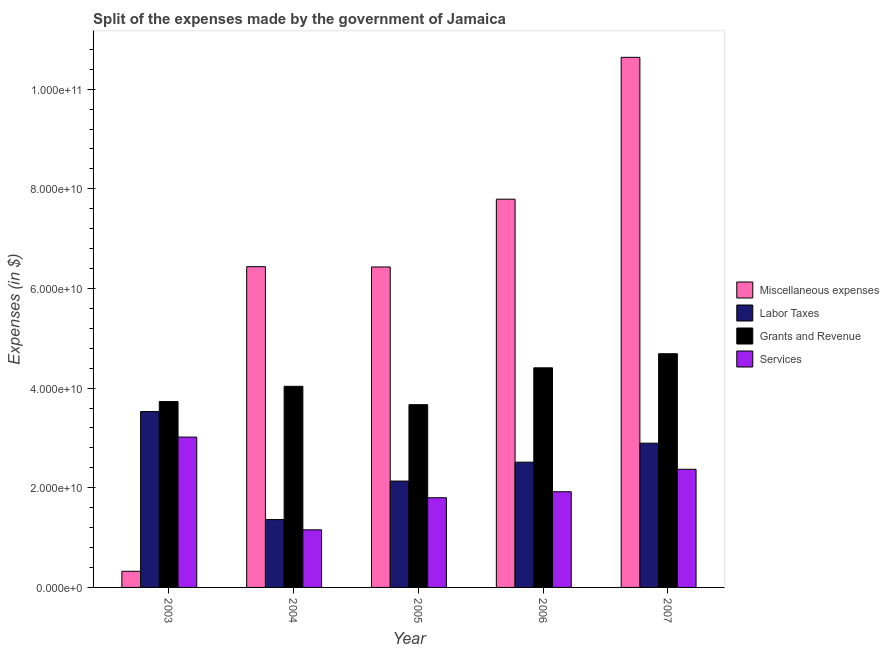How many different coloured bars are there?
Ensure brevity in your answer.  4. Are the number of bars per tick equal to the number of legend labels?
Provide a succinct answer. Yes. Are the number of bars on each tick of the X-axis equal?
Offer a very short reply. Yes. How many bars are there on the 4th tick from the right?
Make the answer very short. 4. In how many cases, is the number of bars for a given year not equal to the number of legend labels?
Give a very brief answer. 0. What is the amount spent on services in 2004?
Keep it short and to the point. 1.16e+1. Across all years, what is the maximum amount spent on services?
Your response must be concise. 3.02e+1. Across all years, what is the minimum amount spent on labor taxes?
Keep it short and to the point. 1.36e+1. In which year was the amount spent on services maximum?
Keep it short and to the point. 2003. In which year was the amount spent on labor taxes minimum?
Provide a succinct answer. 2004. What is the total amount spent on services in the graph?
Your answer should be very brief. 1.03e+11. What is the difference between the amount spent on services in 2003 and that in 2005?
Your answer should be compact. 1.22e+1. What is the difference between the amount spent on grants and revenue in 2004 and the amount spent on services in 2003?
Provide a succinct answer. 3.06e+09. What is the average amount spent on grants and revenue per year?
Give a very brief answer. 4.11e+1. What is the ratio of the amount spent on miscellaneous expenses in 2005 to that in 2007?
Ensure brevity in your answer.  0.6. Is the amount spent on services in 2004 less than that in 2007?
Give a very brief answer. Yes. What is the difference between the highest and the second highest amount spent on grants and revenue?
Provide a succinct answer. 2.83e+09. What is the difference between the highest and the lowest amount spent on labor taxes?
Offer a very short reply. 2.17e+1. What does the 4th bar from the left in 2007 represents?
Offer a very short reply. Services. What does the 4th bar from the right in 2003 represents?
Provide a succinct answer. Miscellaneous expenses. How many bars are there?
Provide a succinct answer. 20. Are all the bars in the graph horizontal?
Make the answer very short. No. How many years are there in the graph?
Provide a succinct answer. 5. Are the values on the major ticks of Y-axis written in scientific E-notation?
Offer a terse response. Yes. Does the graph contain any zero values?
Offer a very short reply. No. Does the graph contain grids?
Your response must be concise. No. How are the legend labels stacked?
Keep it short and to the point. Vertical. What is the title of the graph?
Your answer should be compact. Split of the expenses made by the government of Jamaica. What is the label or title of the Y-axis?
Offer a very short reply. Expenses (in $). What is the Expenses (in $) of Miscellaneous expenses in 2003?
Offer a very short reply. 3.24e+09. What is the Expenses (in $) of Labor Taxes in 2003?
Offer a very short reply. 3.53e+1. What is the Expenses (in $) of Grants and Revenue in 2003?
Give a very brief answer. 3.73e+1. What is the Expenses (in $) in Services in 2003?
Provide a succinct answer. 3.02e+1. What is the Expenses (in $) in Miscellaneous expenses in 2004?
Give a very brief answer. 6.44e+1. What is the Expenses (in $) in Labor Taxes in 2004?
Your answer should be compact. 1.36e+1. What is the Expenses (in $) of Grants and Revenue in 2004?
Keep it short and to the point. 4.04e+1. What is the Expenses (in $) in Services in 2004?
Ensure brevity in your answer.  1.16e+1. What is the Expenses (in $) of Miscellaneous expenses in 2005?
Your response must be concise. 6.43e+1. What is the Expenses (in $) of Labor Taxes in 2005?
Ensure brevity in your answer.  2.14e+1. What is the Expenses (in $) in Grants and Revenue in 2005?
Your answer should be very brief. 3.67e+1. What is the Expenses (in $) in Services in 2005?
Your answer should be compact. 1.80e+1. What is the Expenses (in $) in Miscellaneous expenses in 2006?
Offer a very short reply. 7.79e+1. What is the Expenses (in $) of Labor Taxes in 2006?
Provide a short and direct response. 2.51e+1. What is the Expenses (in $) of Grants and Revenue in 2006?
Provide a succinct answer. 4.41e+1. What is the Expenses (in $) of Services in 2006?
Your answer should be compact. 1.92e+1. What is the Expenses (in $) of Miscellaneous expenses in 2007?
Provide a short and direct response. 1.06e+11. What is the Expenses (in $) in Labor Taxes in 2007?
Make the answer very short. 2.90e+1. What is the Expenses (in $) in Grants and Revenue in 2007?
Your answer should be compact. 4.69e+1. What is the Expenses (in $) in Services in 2007?
Your response must be concise. 2.37e+1. Across all years, what is the maximum Expenses (in $) in Miscellaneous expenses?
Make the answer very short. 1.06e+11. Across all years, what is the maximum Expenses (in $) of Labor Taxes?
Provide a short and direct response. 3.53e+1. Across all years, what is the maximum Expenses (in $) in Grants and Revenue?
Keep it short and to the point. 4.69e+1. Across all years, what is the maximum Expenses (in $) of Services?
Ensure brevity in your answer.  3.02e+1. Across all years, what is the minimum Expenses (in $) of Miscellaneous expenses?
Ensure brevity in your answer.  3.24e+09. Across all years, what is the minimum Expenses (in $) in Labor Taxes?
Ensure brevity in your answer.  1.36e+1. Across all years, what is the minimum Expenses (in $) of Grants and Revenue?
Offer a terse response. 3.67e+1. Across all years, what is the minimum Expenses (in $) of Services?
Offer a very short reply. 1.16e+1. What is the total Expenses (in $) of Miscellaneous expenses in the graph?
Offer a terse response. 3.16e+11. What is the total Expenses (in $) in Labor Taxes in the graph?
Give a very brief answer. 1.24e+11. What is the total Expenses (in $) in Grants and Revenue in the graph?
Offer a very short reply. 2.05e+11. What is the total Expenses (in $) of Services in the graph?
Your answer should be very brief. 1.03e+11. What is the difference between the Expenses (in $) of Miscellaneous expenses in 2003 and that in 2004?
Make the answer very short. -6.11e+1. What is the difference between the Expenses (in $) in Labor Taxes in 2003 and that in 2004?
Provide a short and direct response. 2.17e+1. What is the difference between the Expenses (in $) of Grants and Revenue in 2003 and that in 2004?
Offer a very short reply. -3.06e+09. What is the difference between the Expenses (in $) of Services in 2003 and that in 2004?
Your answer should be compact. 1.86e+1. What is the difference between the Expenses (in $) of Miscellaneous expenses in 2003 and that in 2005?
Provide a succinct answer. -6.11e+1. What is the difference between the Expenses (in $) in Labor Taxes in 2003 and that in 2005?
Your answer should be compact. 1.39e+1. What is the difference between the Expenses (in $) in Grants and Revenue in 2003 and that in 2005?
Ensure brevity in your answer.  6.25e+08. What is the difference between the Expenses (in $) in Services in 2003 and that in 2005?
Provide a succinct answer. 1.22e+1. What is the difference between the Expenses (in $) in Miscellaneous expenses in 2003 and that in 2006?
Provide a succinct answer. -7.47e+1. What is the difference between the Expenses (in $) in Labor Taxes in 2003 and that in 2006?
Your answer should be compact. 1.02e+1. What is the difference between the Expenses (in $) of Grants and Revenue in 2003 and that in 2006?
Your answer should be very brief. -6.77e+09. What is the difference between the Expenses (in $) of Services in 2003 and that in 2006?
Your answer should be very brief. 1.10e+1. What is the difference between the Expenses (in $) in Miscellaneous expenses in 2003 and that in 2007?
Provide a succinct answer. -1.03e+11. What is the difference between the Expenses (in $) in Labor Taxes in 2003 and that in 2007?
Provide a short and direct response. 6.35e+09. What is the difference between the Expenses (in $) of Grants and Revenue in 2003 and that in 2007?
Ensure brevity in your answer.  -9.60e+09. What is the difference between the Expenses (in $) in Services in 2003 and that in 2007?
Your answer should be compact. 6.46e+09. What is the difference between the Expenses (in $) in Miscellaneous expenses in 2004 and that in 2005?
Keep it short and to the point. 6.25e+07. What is the difference between the Expenses (in $) of Labor Taxes in 2004 and that in 2005?
Your answer should be compact. -7.73e+09. What is the difference between the Expenses (in $) of Grants and Revenue in 2004 and that in 2005?
Provide a short and direct response. 3.68e+09. What is the difference between the Expenses (in $) in Services in 2004 and that in 2005?
Offer a terse response. -6.44e+09. What is the difference between the Expenses (in $) of Miscellaneous expenses in 2004 and that in 2006?
Make the answer very short. -1.35e+1. What is the difference between the Expenses (in $) of Labor Taxes in 2004 and that in 2006?
Offer a very short reply. -1.15e+1. What is the difference between the Expenses (in $) of Grants and Revenue in 2004 and that in 2006?
Ensure brevity in your answer.  -3.71e+09. What is the difference between the Expenses (in $) of Services in 2004 and that in 2006?
Provide a short and direct response. -7.64e+09. What is the difference between the Expenses (in $) of Miscellaneous expenses in 2004 and that in 2007?
Keep it short and to the point. -4.20e+1. What is the difference between the Expenses (in $) in Labor Taxes in 2004 and that in 2007?
Offer a very short reply. -1.53e+1. What is the difference between the Expenses (in $) of Grants and Revenue in 2004 and that in 2007?
Offer a very short reply. -6.54e+09. What is the difference between the Expenses (in $) of Services in 2004 and that in 2007?
Keep it short and to the point. -1.22e+1. What is the difference between the Expenses (in $) of Miscellaneous expenses in 2005 and that in 2006?
Your response must be concise. -1.36e+1. What is the difference between the Expenses (in $) of Labor Taxes in 2005 and that in 2006?
Keep it short and to the point. -3.79e+09. What is the difference between the Expenses (in $) in Grants and Revenue in 2005 and that in 2006?
Your response must be concise. -7.40e+09. What is the difference between the Expenses (in $) of Services in 2005 and that in 2006?
Offer a very short reply. -1.20e+09. What is the difference between the Expenses (in $) in Miscellaneous expenses in 2005 and that in 2007?
Provide a short and direct response. -4.21e+1. What is the difference between the Expenses (in $) in Labor Taxes in 2005 and that in 2007?
Give a very brief answer. -7.60e+09. What is the difference between the Expenses (in $) in Grants and Revenue in 2005 and that in 2007?
Make the answer very short. -1.02e+1. What is the difference between the Expenses (in $) in Services in 2005 and that in 2007?
Your response must be concise. -5.71e+09. What is the difference between the Expenses (in $) of Miscellaneous expenses in 2006 and that in 2007?
Keep it short and to the point. -2.85e+1. What is the difference between the Expenses (in $) in Labor Taxes in 2006 and that in 2007?
Offer a terse response. -3.81e+09. What is the difference between the Expenses (in $) of Grants and Revenue in 2006 and that in 2007?
Your answer should be compact. -2.83e+09. What is the difference between the Expenses (in $) of Services in 2006 and that in 2007?
Make the answer very short. -4.51e+09. What is the difference between the Expenses (in $) in Miscellaneous expenses in 2003 and the Expenses (in $) in Labor Taxes in 2004?
Your answer should be very brief. -1.04e+1. What is the difference between the Expenses (in $) in Miscellaneous expenses in 2003 and the Expenses (in $) in Grants and Revenue in 2004?
Keep it short and to the point. -3.71e+1. What is the difference between the Expenses (in $) of Miscellaneous expenses in 2003 and the Expenses (in $) of Services in 2004?
Keep it short and to the point. -8.32e+09. What is the difference between the Expenses (in $) in Labor Taxes in 2003 and the Expenses (in $) in Grants and Revenue in 2004?
Keep it short and to the point. -5.06e+09. What is the difference between the Expenses (in $) in Labor Taxes in 2003 and the Expenses (in $) in Services in 2004?
Ensure brevity in your answer.  2.37e+1. What is the difference between the Expenses (in $) of Grants and Revenue in 2003 and the Expenses (in $) of Services in 2004?
Offer a very short reply. 2.57e+1. What is the difference between the Expenses (in $) in Miscellaneous expenses in 2003 and the Expenses (in $) in Labor Taxes in 2005?
Offer a very short reply. -1.81e+1. What is the difference between the Expenses (in $) of Miscellaneous expenses in 2003 and the Expenses (in $) of Grants and Revenue in 2005?
Make the answer very short. -3.34e+1. What is the difference between the Expenses (in $) in Miscellaneous expenses in 2003 and the Expenses (in $) in Services in 2005?
Give a very brief answer. -1.48e+1. What is the difference between the Expenses (in $) of Labor Taxes in 2003 and the Expenses (in $) of Grants and Revenue in 2005?
Provide a succinct answer. -1.38e+09. What is the difference between the Expenses (in $) in Labor Taxes in 2003 and the Expenses (in $) in Services in 2005?
Offer a terse response. 1.73e+1. What is the difference between the Expenses (in $) of Grants and Revenue in 2003 and the Expenses (in $) of Services in 2005?
Give a very brief answer. 1.93e+1. What is the difference between the Expenses (in $) of Miscellaneous expenses in 2003 and the Expenses (in $) of Labor Taxes in 2006?
Your answer should be compact. -2.19e+1. What is the difference between the Expenses (in $) of Miscellaneous expenses in 2003 and the Expenses (in $) of Grants and Revenue in 2006?
Offer a terse response. -4.08e+1. What is the difference between the Expenses (in $) of Miscellaneous expenses in 2003 and the Expenses (in $) of Services in 2006?
Offer a terse response. -1.60e+1. What is the difference between the Expenses (in $) of Labor Taxes in 2003 and the Expenses (in $) of Grants and Revenue in 2006?
Provide a short and direct response. -8.78e+09. What is the difference between the Expenses (in $) of Labor Taxes in 2003 and the Expenses (in $) of Services in 2006?
Your answer should be very brief. 1.61e+1. What is the difference between the Expenses (in $) of Grants and Revenue in 2003 and the Expenses (in $) of Services in 2006?
Your response must be concise. 1.81e+1. What is the difference between the Expenses (in $) in Miscellaneous expenses in 2003 and the Expenses (in $) in Labor Taxes in 2007?
Offer a terse response. -2.57e+1. What is the difference between the Expenses (in $) in Miscellaneous expenses in 2003 and the Expenses (in $) in Grants and Revenue in 2007?
Provide a short and direct response. -4.37e+1. What is the difference between the Expenses (in $) of Miscellaneous expenses in 2003 and the Expenses (in $) of Services in 2007?
Your answer should be compact. -2.05e+1. What is the difference between the Expenses (in $) in Labor Taxes in 2003 and the Expenses (in $) in Grants and Revenue in 2007?
Your answer should be compact. -1.16e+1. What is the difference between the Expenses (in $) of Labor Taxes in 2003 and the Expenses (in $) of Services in 2007?
Offer a terse response. 1.16e+1. What is the difference between the Expenses (in $) of Grants and Revenue in 2003 and the Expenses (in $) of Services in 2007?
Provide a short and direct response. 1.36e+1. What is the difference between the Expenses (in $) of Miscellaneous expenses in 2004 and the Expenses (in $) of Labor Taxes in 2005?
Keep it short and to the point. 4.30e+1. What is the difference between the Expenses (in $) in Miscellaneous expenses in 2004 and the Expenses (in $) in Grants and Revenue in 2005?
Offer a terse response. 2.77e+1. What is the difference between the Expenses (in $) in Miscellaneous expenses in 2004 and the Expenses (in $) in Services in 2005?
Ensure brevity in your answer.  4.64e+1. What is the difference between the Expenses (in $) of Labor Taxes in 2004 and the Expenses (in $) of Grants and Revenue in 2005?
Offer a very short reply. -2.31e+1. What is the difference between the Expenses (in $) in Labor Taxes in 2004 and the Expenses (in $) in Services in 2005?
Offer a very short reply. -4.38e+09. What is the difference between the Expenses (in $) in Grants and Revenue in 2004 and the Expenses (in $) in Services in 2005?
Provide a short and direct response. 2.24e+1. What is the difference between the Expenses (in $) of Miscellaneous expenses in 2004 and the Expenses (in $) of Labor Taxes in 2006?
Your answer should be compact. 3.92e+1. What is the difference between the Expenses (in $) of Miscellaneous expenses in 2004 and the Expenses (in $) of Grants and Revenue in 2006?
Offer a very short reply. 2.03e+1. What is the difference between the Expenses (in $) of Miscellaneous expenses in 2004 and the Expenses (in $) of Services in 2006?
Your answer should be very brief. 4.52e+1. What is the difference between the Expenses (in $) of Labor Taxes in 2004 and the Expenses (in $) of Grants and Revenue in 2006?
Make the answer very short. -3.05e+1. What is the difference between the Expenses (in $) of Labor Taxes in 2004 and the Expenses (in $) of Services in 2006?
Your answer should be compact. -5.58e+09. What is the difference between the Expenses (in $) in Grants and Revenue in 2004 and the Expenses (in $) in Services in 2006?
Give a very brief answer. 2.12e+1. What is the difference between the Expenses (in $) of Miscellaneous expenses in 2004 and the Expenses (in $) of Labor Taxes in 2007?
Your answer should be very brief. 3.54e+1. What is the difference between the Expenses (in $) in Miscellaneous expenses in 2004 and the Expenses (in $) in Grants and Revenue in 2007?
Offer a terse response. 1.75e+1. What is the difference between the Expenses (in $) in Miscellaneous expenses in 2004 and the Expenses (in $) in Services in 2007?
Provide a succinct answer. 4.07e+1. What is the difference between the Expenses (in $) of Labor Taxes in 2004 and the Expenses (in $) of Grants and Revenue in 2007?
Provide a succinct answer. -3.33e+1. What is the difference between the Expenses (in $) in Labor Taxes in 2004 and the Expenses (in $) in Services in 2007?
Provide a succinct answer. -1.01e+1. What is the difference between the Expenses (in $) of Grants and Revenue in 2004 and the Expenses (in $) of Services in 2007?
Make the answer very short. 1.66e+1. What is the difference between the Expenses (in $) of Miscellaneous expenses in 2005 and the Expenses (in $) of Labor Taxes in 2006?
Your answer should be compact. 3.92e+1. What is the difference between the Expenses (in $) of Miscellaneous expenses in 2005 and the Expenses (in $) of Grants and Revenue in 2006?
Offer a very short reply. 2.02e+1. What is the difference between the Expenses (in $) in Miscellaneous expenses in 2005 and the Expenses (in $) in Services in 2006?
Make the answer very short. 4.51e+1. What is the difference between the Expenses (in $) of Labor Taxes in 2005 and the Expenses (in $) of Grants and Revenue in 2006?
Give a very brief answer. -2.27e+1. What is the difference between the Expenses (in $) of Labor Taxes in 2005 and the Expenses (in $) of Services in 2006?
Keep it short and to the point. 2.15e+09. What is the difference between the Expenses (in $) of Grants and Revenue in 2005 and the Expenses (in $) of Services in 2006?
Offer a very short reply. 1.75e+1. What is the difference between the Expenses (in $) in Miscellaneous expenses in 2005 and the Expenses (in $) in Labor Taxes in 2007?
Offer a terse response. 3.54e+1. What is the difference between the Expenses (in $) in Miscellaneous expenses in 2005 and the Expenses (in $) in Grants and Revenue in 2007?
Offer a very short reply. 1.74e+1. What is the difference between the Expenses (in $) in Miscellaneous expenses in 2005 and the Expenses (in $) in Services in 2007?
Offer a very short reply. 4.06e+1. What is the difference between the Expenses (in $) of Labor Taxes in 2005 and the Expenses (in $) of Grants and Revenue in 2007?
Offer a very short reply. -2.56e+1. What is the difference between the Expenses (in $) of Labor Taxes in 2005 and the Expenses (in $) of Services in 2007?
Ensure brevity in your answer.  -2.36e+09. What is the difference between the Expenses (in $) of Grants and Revenue in 2005 and the Expenses (in $) of Services in 2007?
Keep it short and to the point. 1.30e+1. What is the difference between the Expenses (in $) in Miscellaneous expenses in 2006 and the Expenses (in $) in Labor Taxes in 2007?
Offer a very short reply. 4.90e+1. What is the difference between the Expenses (in $) in Miscellaneous expenses in 2006 and the Expenses (in $) in Grants and Revenue in 2007?
Your response must be concise. 3.10e+1. What is the difference between the Expenses (in $) of Miscellaneous expenses in 2006 and the Expenses (in $) of Services in 2007?
Your response must be concise. 5.42e+1. What is the difference between the Expenses (in $) of Labor Taxes in 2006 and the Expenses (in $) of Grants and Revenue in 2007?
Provide a succinct answer. -2.18e+1. What is the difference between the Expenses (in $) in Labor Taxes in 2006 and the Expenses (in $) in Services in 2007?
Your answer should be compact. 1.43e+09. What is the difference between the Expenses (in $) of Grants and Revenue in 2006 and the Expenses (in $) of Services in 2007?
Offer a terse response. 2.04e+1. What is the average Expenses (in $) in Miscellaneous expenses per year?
Provide a short and direct response. 6.33e+1. What is the average Expenses (in $) of Labor Taxes per year?
Ensure brevity in your answer.  2.49e+1. What is the average Expenses (in $) in Grants and Revenue per year?
Keep it short and to the point. 4.11e+1. What is the average Expenses (in $) of Services per year?
Provide a succinct answer. 2.05e+1. In the year 2003, what is the difference between the Expenses (in $) of Miscellaneous expenses and Expenses (in $) of Labor Taxes?
Your answer should be compact. -3.21e+1. In the year 2003, what is the difference between the Expenses (in $) of Miscellaneous expenses and Expenses (in $) of Grants and Revenue?
Offer a terse response. -3.41e+1. In the year 2003, what is the difference between the Expenses (in $) of Miscellaneous expenses and Expenses (in $) of Services?
Your response must be concise. -2.69e+1. In the year 2003, what is the difference between the Expenses (in $) of Labor Taxes and Expenses (in $) of Grants and Revenue?
Provide a short and direct response. -2.01e+09. In the year 2003, what is the difference between the Expenses (in $) of Labor Taxes and Expenses (in $) of Services?
Give a very brief answer. 5.13e+09. In the year 2003, what is the difference between the Expenses (in $) of Grants and Revenue and Expenses (in $) of Services?
Keep it short and to the point. 7.13e+09. In the year 2004, what is the difference between the Expenses (in $) of Miscellaneous expenses and Expenses (in $) of Labor Taxes?
Give a very brief answer. 5.08e+1. In the year 2004, what is the difference between the Expenses (in $) in Miscellaneous expenses and Expenses (in $) in Grants and Revenue?
Ensure brevity in your answer.  2.40e+1. In the year 2004, what is the difference between the Expenses (in $) of Miscellaneous expenses and Expenses (in $) of Services?
Your answer should be very brief. 5.28e+1. In the year 2004, what is the difference between the Expenses (in $) of Labor Taxes and Expenses (in $) of Grants and Revenue?
Your answer should be very brief. -2.67e+1. In the year 2004, what is the difference between the Expenses (in $) of Labor Taxes and Expenses (in $) of Services?
Ensure brevity in your answer.  2.06e+09. In the year 2004, what is the difference between the Expenses (in $) of Grants and Revenue and Expenses (in $) of Services?
Give a very brief answer. 2.88e+1. In the year 2005, what is the difference between the Expenses (in $) of Miscellaneous expenses and Expenses (in $) of Labor Taxes?
Keep it short and to the point. 4.30e+1. In the year 2005, what is the difference between the Expenses (in $) in Miscellaneous expenses and Expenses (in $) in Grants and Revenue?
Your answer should be compact. 2.76e+1. In the year 2005, what is the difference between the Expenses (in $) of Miscellaneous expenses and Expenses (in $) of Services?
Offer a terse response. 4.63e+1. In the year 2005, what is the difference between the Expenses (in $) in Labor Taxes and Expenses (in $) in Grants and Revenue?
Your response must be concise. -1.53e+1. In the year 2005, what is the difference between the Expenses (in $) in Labor Taxes and Expenses (in $) in Services?
Ensure brevity in your answer.  3.35e+09. In the year 2005, what is the difference between the Expenses (in $) in Grants and Revenue and Expenses (in $) in Services?
Ensure brevity in your answer.  1.87e+1. In the year 2006, what is the difference between the Expenses (in $) of Miscellaneous expenses and Expenses (in $) of Labor Taxes?
Your response must be concise. 5.28e+1. In the year 2006, what is the difference between the Expenses (in $) in Miscellaneous expenses and Expenses (in $) in Grants and Revenue?
Provide a succinct answer. 3.38e+1. In the year 2006, what is the difference between the Expenses (in $) in Miscellaneous expenses and Expenses (in $) in Services?
Provide a succinct answer. 5.87e+1. In the year 2006, what is the difference between the Expenses (in $) of Labor Taxes and Expenses (in $) of Grants and Revenue?
Make the answer very short. -1.89e+1. In the year 2006, what is the difference between the Expenses (in $) of Labor Taxes and Expenses (in $) of Services?
Your response must be concise. 5.94e+09. In the year 2006, what is the difference between the Expenses (in $) of Grants and Revenue and Expenses (in $) of Services?
Give a very brief answer. 2.49e+1. In the year 2007, what is the difference between the Expenses (in $) of Miscellaneous expenses and Expenses (in $) of Labor Taxes?
Your response must be concise. 7.74e+1. In the year 2007, what is the difference between the Expenses (in $) of Miscellaneous expenses and Expenses (in $) of Grants and Revenue?
Provide a succinct answer. 5.95e+1. In the year 2007, what is the difference between the Expenses (in $) of Miscellaneous expenses and Expenses (in $) of Services?
Provide a short and direct response. 8.27e+1. In the year 2007, what is the difference between the Expenses (in $) in Labor Taxes and Expenses (in $) in Grants and Revenue?
Keep it short and to the point. -1.80e+1. In the year 2007, what is the difference between the Expenses (in $) in Labor Taxes and Expenses (in $) in Services?
Your answer should be very brief. 5.24e+09. In the year 2007, what is the difference between the Expenses (in $) in Grants and Revenue and Expenses (in $) in Services?
Your answer should be compact. 2.32e+1. What is the ratio of the Expenses (in $) of Miscellaneous expenses in 2003 to that in 2004?
Keep it short and to the point. 0.05. What is the ratio of the Expenses (in $) in Labor Taxes in 2003 to that in 2004?
Give a very brief answer. 2.59. What is the ratio of the Expenses (in $) of Grants and Revenue in 2003 to that in 2004?
Your answer should be compact. 0.92. What is the ratio of the Expenses (in $) of Services in 2003 to that in 2004?
Offer a very short reply. 2.61. What is the ratio of the Expenses (in $) of Miscellaneous expenses in 2003 to that in 2005?
Your answer should be very brief. 0.05. What is the ratio of the Expenses (in $) in Labor Taxes in 2003 to that in 2005?
Make the answer very short. 1.65. What is the ratio of the Expenses (in $) of Services in 2003 to that in 2005?
Make the answer very short. 1.68. What is the ratio of the Expenses (in $) in Miscellaneous expenses in 2003 to that in 2006?
Your answer should be very brief. 0.04. What is the ratio of the Expenses (in $) of Labor Taxes in 2003 to that in 2006?
Your answer should be compact. 1.4. What is the ratio of the Expenses (in $) in Grants and Revenue in 2003 to that in 2006?
Keep it short and to the point. 0.85. What is the ratio of the Expenses (in $) of Services in 2003 to that in 2006?
Offer a terse response. 1.57. What is the ratio of the Expenses (in $) in Miscellaneous expenses in 2003 to that in 2007?
Ensure brevity in your answer.  0.03. What is the ratio of the Expenses (in $) in Labor Taxes in 2003 to that in 2007?
Give a very brief answer. 1.22. What is the ratio of the Expenses (in $) of Grants and Revenue in 2003 to that in 2007?
Ensure brevity in your answer.  0.8. What is the ratio of the Expenses (in $) of Services in 2003 to that in 2007?
Provide a succinct answer. 1.27. What is the ratio of the Expenses (in $) in Labor Taxes in 2004 to that in 2005?
Provide a succinct answer. 0.64. What is the ratio of the Expenses (in $) in Grants and Revenue in 2004 to that in 2005?
Your answer should be very brief. 1.1. What is the ratio of the Expenses (in $) of Services in 2004 to that in 2005?
Provide a succinct answer. 0.64. What is the ratio of the Expenses (in $) in Miscellaneous expenses in 2004 to that in 2006?
Provide a succinct answer. 0.83. What is the ratio of the Expenses (in $) of Labor Taxes in 2004 to that in 2006?
Offer a terse response. 0.54. What is the ratio of the Expenses (in $) of Grants and Revenue in 2004 to that in 2006?
Your answer should be compact. 0.92. What is the ratio of the Expenses (in $) of Services in 2004 to that in 2006?
Your response must be concise. 0.6. What is the ratio of the Expenses (in $) of Miscellaneous expenses in 2004 to that in 2007?
Provide a short and direct response. 0.61. What is the ratio of the Expenses (in $) in Labor Taxes in 2004 to that in 2007?
Make the answer very short. 0.47. What is the ratio of the Expenses (in $) of Grants and Revenue in 2004 to that in 2007?
Your answer should be very brief. 0.86. What is the ratio of the Expenses (in $) in Services in 2004 to that in 2007?
Provide a short and direct response. 0.49. What is the ratio of the Expenses (in $) in Miscellaneous expenses in 2005 to that in 2006?
Your answer should be compact. 0.83. What is the ratio of the Expenses (in $) of Labor Taxes in 2005 to that in 2006?
Give a very brief answer. 0.85. What is the ratio of the Expenses (in $) in Grants and Revenue in 2005 to that in 2006?
Ensure brevity in your answer.  0.83. What is the ratio of the Expenses (in $) of Services in 2005 to that in 2006?
Your answer should be very brief. 0.94. What is the ratio of the Expenses (in $) in Miscellaneous expenses in 2005 to that in 2007?
Give a very brief answer. 0.6. What is the ratio of the Expenses (in $) in Labor Taxes in 2005 to that in 2007?
Make the answer very short. 0.74. What is the ratio of the Expenses (in $) of Grants and Revenue in 2005 to that in 2007?
Make the answer very short. 0.78. What is the ratio of the Expenses (in $) in Services in 2005 to that in 2007?
Your answer should be compact. 0.76. What is the ratio of the Expenses (in $) in Miscellaneous expenses in 2006 to that in 2007?
Provide a succinct answer. 0.73. What is the ratio of the Expenses (in $) of Labor Taxes in 2006 to that in 2007?
Your answer should be compact. 0.87. What is the ratio of the Expenses (in $) of Grants and Revenue in 2006 to that in 2007?
Your answer should be very brief. 0.94. What is the ratio of the Expenses (in $) in Services in 2006 to that in 2007?
Provide a succinct answer. 0.81. What is the difference between the highest and the second highest Expenses (in $) of Miscellaneous expenses?
Offer a terse response. 2.85e+1. What is the difference between the highest and the second highest Expenses (in $) of Labor Taxes?
Provide a short and direct response. 6.35e+09. What is the difference between the highest and the second highest Expenses (in $) in Grants and Revenue?
Your answer should be very brief. 2.83e+09. What is the difference between the highest and the second highest Expenses (in $) of Services?
Provide a short and direct response. 6.46e+09. What is the difference between the highest and the lowest Expenses (in $) in Miscellaneous expenses?
Give a very brief answer. 1.03e+11. What is the difference between the highest and the lowest Expenses (in $) of Labor Taxes?
Your answer should be very brief. 2.17e+1. What is the difference between the highest and the lowest Expenses (in $) in Grants and Revenue?
Keep it short and to the point. 1.02e+1. What is the difference between the highest and the lowest Expenses (in $) of Services?
Offer a terse response. 1.86e+1. 